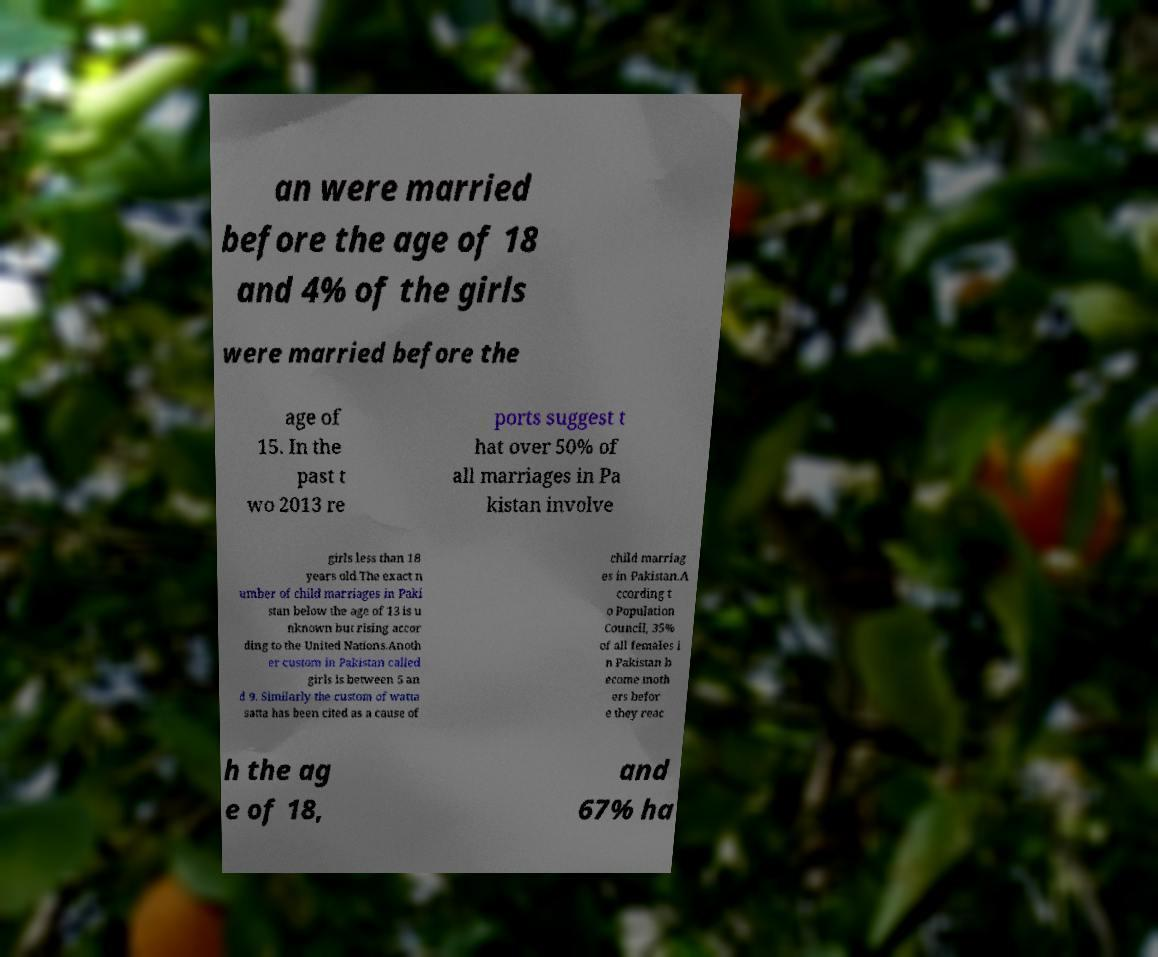Please identify and transcribe the text found in this image. an were married before the age of 18 and 4% of the girls were married before the age of 15. In the past t wo 2013 re ports suggest t hat over 50% of all marriages in Pa kistan involve girls less than 18 years old.The exact n umber of child marriages in Paki stan below the age of 13 is u nknown but rising accor ding to the United Nations.Anoth er custom in Pakistan called girls is between 5 an d 9. Similarly the custom of watta satta has been cited as a cause of child marriag es in Pakistan.A ccording t o Population Council, 35% of all females i n Pakistan b ecome moth ers befor e they reac h the ag e of 18, and 67% ha 